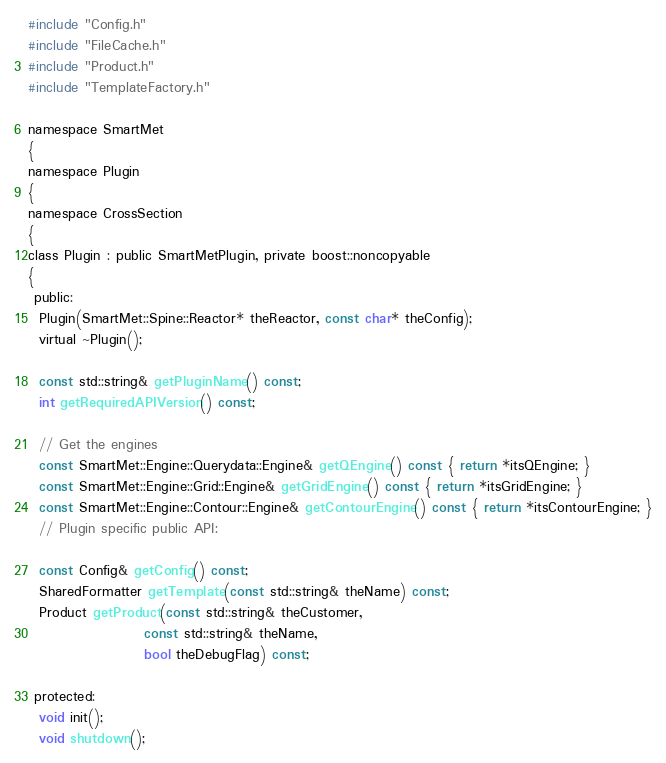<code> <loc_0><loc_0><loc_500><loc_500><_C_>#include "Config.h"
#include "FileCache.h"
#include "Product.h"
#include "TemplateFactory.h"

namespace SmartMet
{
namespace Plugin
{
namespace CrossSection
{
class Plugin : public SmartMetPlugin, private boost::noncopyable
{
 public:
  Plugin(SmartMet::Spine::Reactor* theReactor, const char* theConfig);
  virtual ~Plugin();

  const std::string& getPluginName() const;
  int getRequiredAPIVersion() const;

  // Get the engines
  const SmartMet::Engine::Querydata::Engine& getQEngine() const { return *itsQEngine; }
  const SmartMet::Engine::Grid::Engine& getGridEngine() const { return *itsGridEngine; }
  const SmartMet::Engine::Contour::Engine& getContourEngine() const { return *itsContourEngine; }
  // Plugin specific public API:

  const Config& getConfig() const;
  SharedFormatter getTemplate(const std::string& theName) const;
  Product getProduct(const std::string& theCustomer,
                     const std::string& theName,
                     bool theDebugFlag) const;

 protected:
  void init();
  void shutdown();</code> 